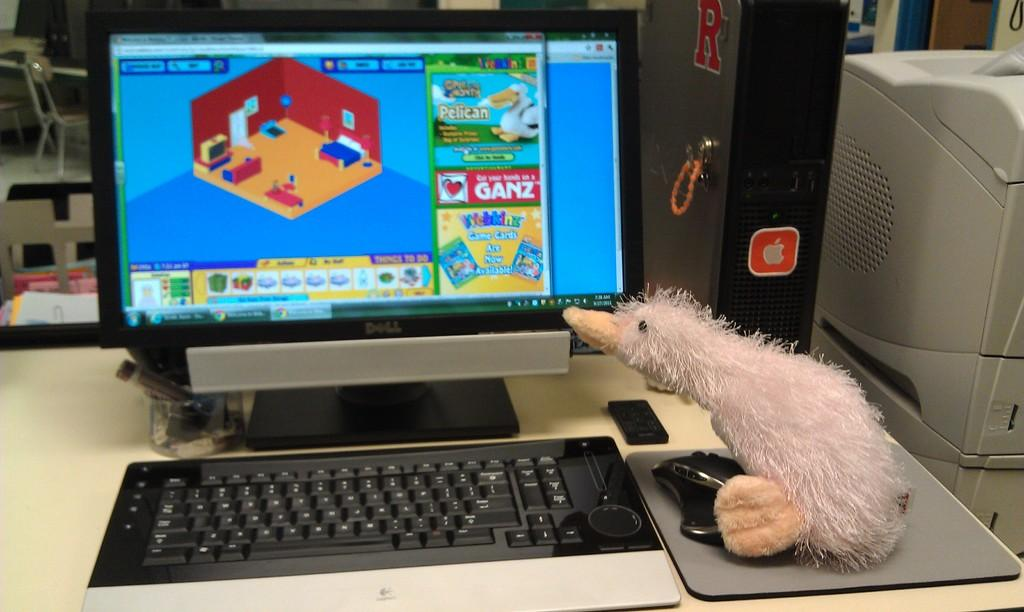<image>
Offer a succinct explanation of the picture presented. Toy duck looking at the monitor of a computer screen that says GANZ on it. 